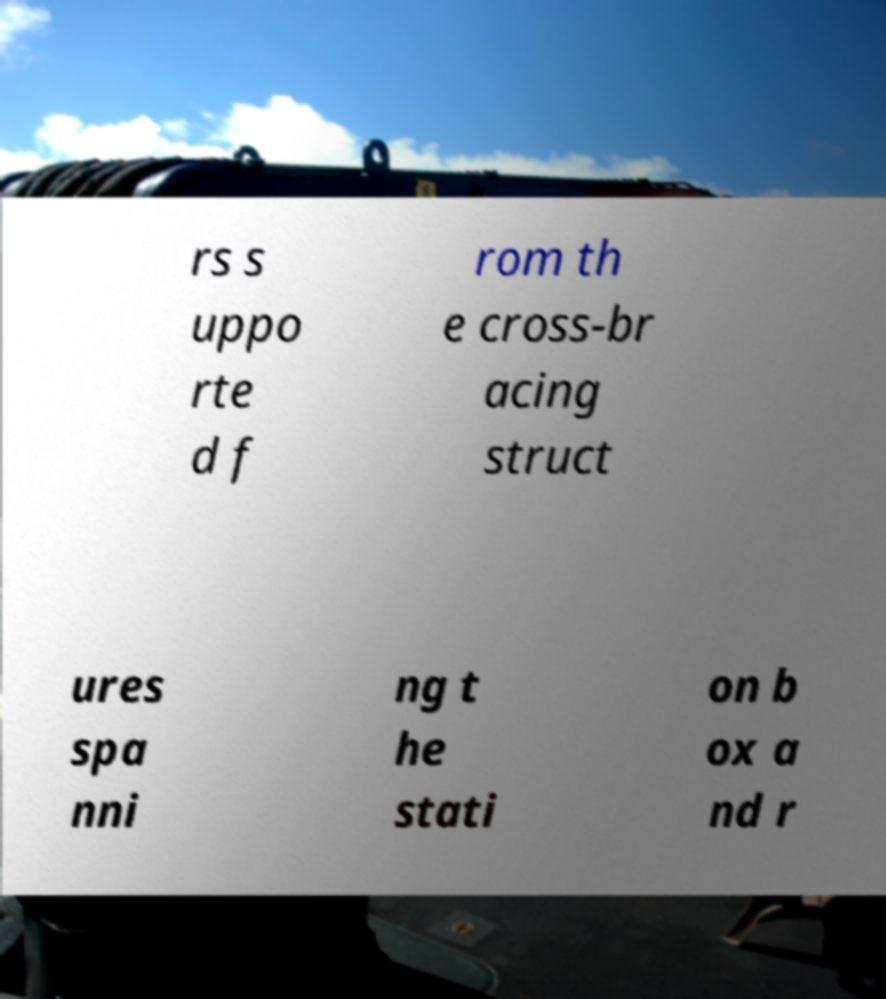I need the written content from this picture converted into text. Can you do that? rs s uppo rte d f rom th e cross-br acing struct ures spa nni ng t he stati on b ox a nd r 